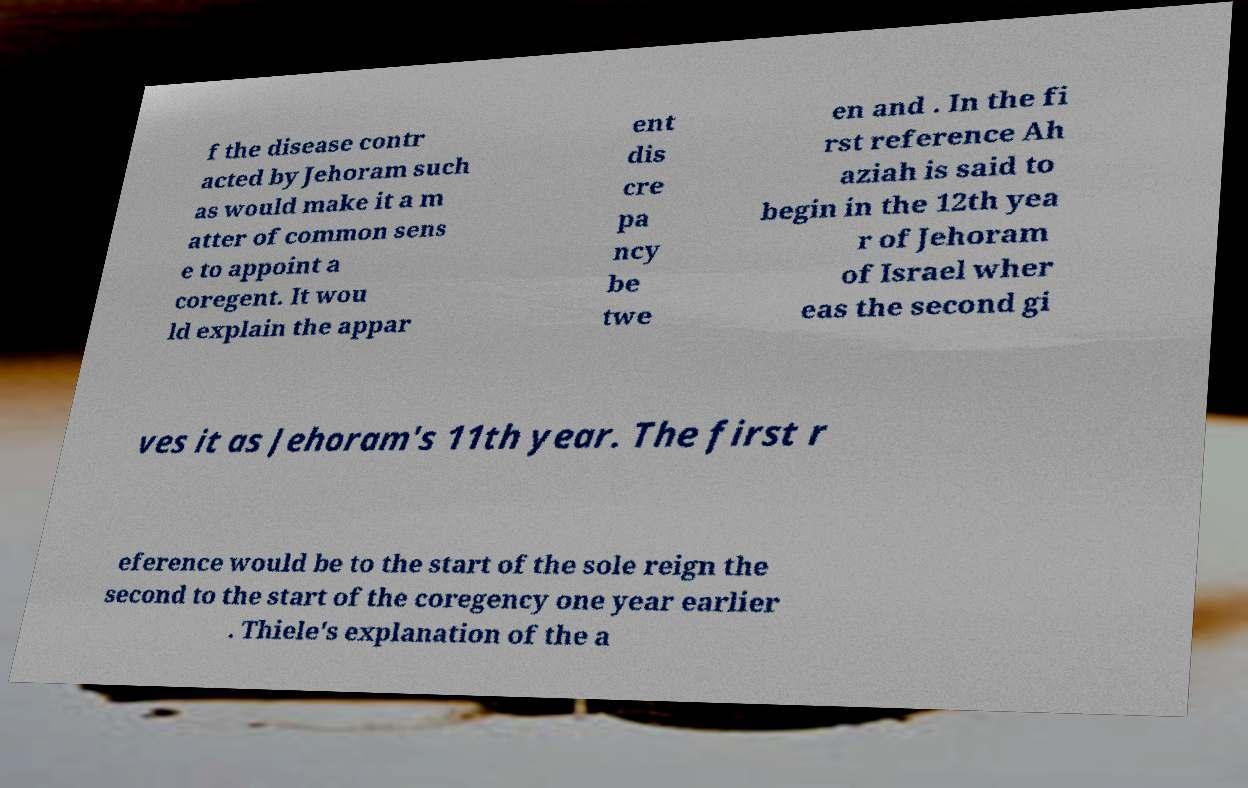What messages or text are displayed in this image? I need them in a readable, typed format. f the disease contr acted by Jehoram such as would make it a m atter of common sens e to appoint a coregent. It wou ld explain the appar ent dis cre pa ncy be twe en and . In the fi rst reference Ah aziah is said to begin in the 12th yea r of Jehoram of Israel wher eas the second gi ves it as Jehoram's 11th year. The first r eference would be to the start of the sole reign the second to the start of the coregency one year earlier . Thiele's explanation of the a 